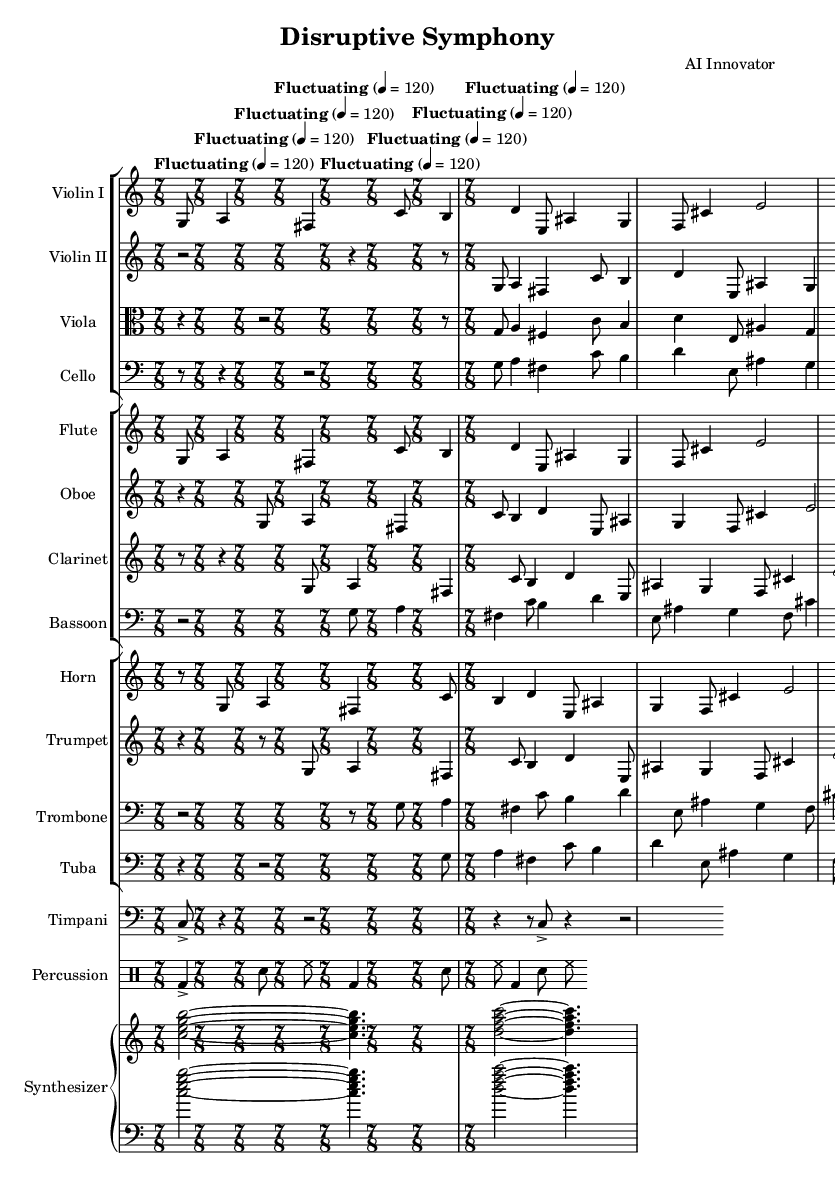what is the time signature of this music? The time signature is located at the beginning of the piece and is indicated as 7/8, which means there are seven eighth notes in each measure.
Answer: 7/8 what is the tempo marking of this symphony? The tempo marking at the beginning of the score is indicated as "Fluctuating" with a metronome marking of 4 = 120, meaning the piece should be played at a fluctuating tempo with a quarter note equalling 120 beats per minute.
Answer: Fluctuating how many instruments are featured in this symphony? By counting the different staves in the score, there are a total of 12 distinct instruments including two violin parts, viola, cello, flute, oboe, clarinet, bassoon, horn, trumpet, trombone, tuba, timpani, percussion, and synthesizer.
Answer: 12 which instrument has a continuous pedal point in this symphony? The synthesizer part includes sustained chords that create a continuous sound throughout the piece, indicating a pedal point, which contrasts with the more rhythmic and fragmented elements of the other instruments.
Answer: Synthesizer what is the predominant texture of the symphony? The score indicates a rich polyphonic texture with multiple independent melodies occurring concurrently, particularly evident in the layering of different instruments like strings, woodwinds, and the synthesizer, creating a complex interplay.
Answer: Polyphonic how does the use of silence vary among instruments? Observing the rests marked in various instruments throughout the score, some sections such as the cello and viola have extended periods of silence, while other instruments like the flute and percussion maintain more consistent activity, showcasing a contrast in dynamics and textural density.
Answer: Varies significantly 